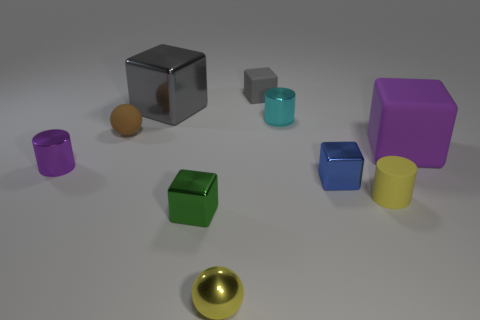There is a big metallic object that is the same color as the small rubber block; what is its shape?
Keep it short and to the point. Cube. There is a matte thing that is the same color as the metal ball; what is its size?
Offer a very short reply. Small. How many cylinders are either tiny blue metallic objects or tiny objects?
Provide a short and direct response. 3. The yellow matte cylinder has what size?
Your response must be concise. Small. There is a gray matte block; what number of tiny purple shiny cylinders are behind it?
Ensure brevity in your answer.  0. There is a yellow rubber cylinder right of the tiny metal block in front of the yellow rubber object; how big is it?
Provide a short and direct response. Small. Does the matte thing on the left side of the tiny green block have the same shape as the small object in front of the green metallic block?
Your answer should be very brief. Yes. The large object to the left of the rubber object to the right of the small yellow rubber cylinder is what shape?
Keep it short and to the point. Cube. What is the size of the metal cube that is right of the big gray shiny object and to the left of the metallic ball?
Keep it short and to the point. Small. Does the small gray thing have the same shape as the purple thing that is to the left of the yellow metal thing?
Offer a very short reply. No. 